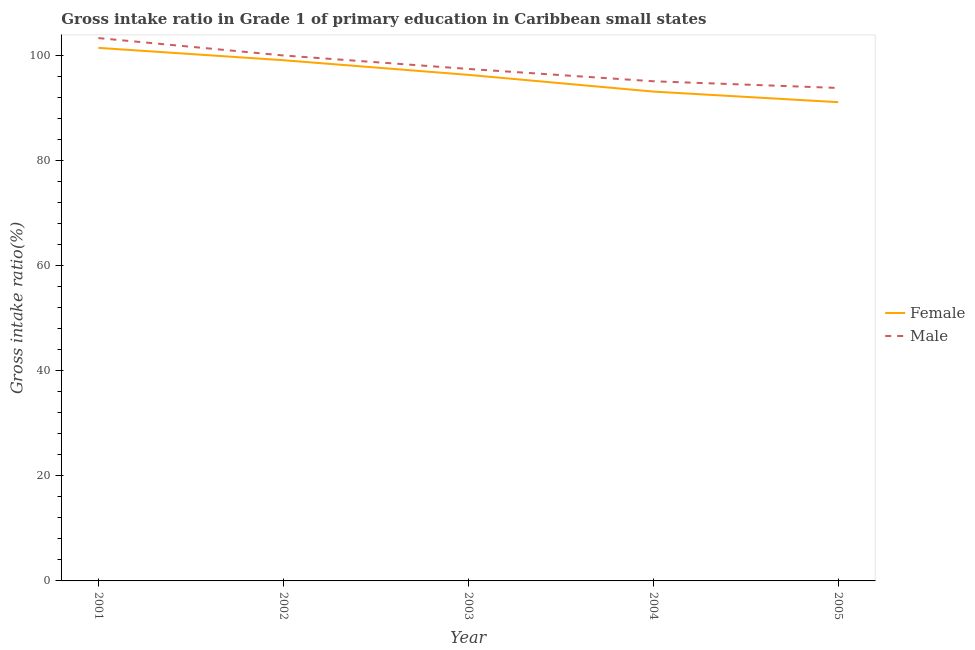How many different coloured lines are there?
Provide a short and direct response. 2. What is the gross intake ratio(male) in 2004?
Offer a very short reply. 95.14. Across all years, what is the maximum gross intake ratio(male)?
Offer a very short reply. 103.36. Across all years, what is the minimum gross intake ratio(female)?
Offer a terse response. 91.16. What is the total gross intake ratio(female) in the graph?
Offer a terse response. 481.33. What is the difference between the gross intake ratio(female) in 2004 and that in 2005?
Your response must be concise. 2.02. What is the difference between the gross intake ratio(female) in 2005 and the gross intake ratio(male) in 2001?
Your response must be concise. -12.2. What is the average gross intake ratio(male) per year?
Your response must be concise. 97.98. In the year 2005, what is the difference between the gross intake ratio(female) and gross intake ratio(male)?
Your answer should be very brief. -2.71. What is the ratio of the gross intake ratio(male) in 2004 to that in 2005?
Make the answer very short. 1.01. What is the difference between the highest and the second highest gross intake ratio(female)?
Offer a very short reply. 2.35. What is the difference between the highest and the lowest gross intake ratio(female)?
Your response must be concise. 10.34. In how many years, is the gross intake ratio(male) greater than the average gross intake ratio(male) taken over all years?
Ensure brevity in your answer.  2. Does the gross intake ratio(female) monotonically increase over the years?
Your response must be concise. No. Is the gross intake ratio(male) strictly greater than the gross intake ratio(female) over the years?
Your response must be concise. Yes. How many years are there in the graph?
Offer a very short reply. 5. What is the difference between two consecutive major ticks on the Y-axis?
Offer a very short reply. 20. Are the values on the major ticks of Y-axis written in scientific E-notation?
Your response must be concise. No. Does the graph contain grids?
Provide a short and direct response. No. How many legend labels are there?
Give a very brief answer. 2. How are the legend labels stacked?
Provide a succinct answer. Vertical. What is the title of the graph?
Your answer should be very brief. Gross intake ratio in Grade 1 of primary education in Caribbean small states. Does "GDP per capita" appear as one of the legend labels in the graph?
Your response must be concise. No. What is the label or title of the Y-axis?
Offer a terse response. Gross intake ratio(%). What is the Gross intake ratio(%) in Female in 2001?
Ensure brevity in your answer.  101.5. What is the Gross intake ratio(%) in Male in 2001?
Offer a very short reply. 103.36. What is the Gross intake ratio(%) of Female in 2002?
Give a very brief answer. 99.15. What is the Gross intake ratio(%) in Male in 2002?
Your answer should be very brief. 100.05. What is the Gross intake ratio(%) in Female in 2003?
Your answer should be very brief. 96.36. What is the Gross intake ratio(%) in Male in 2003?
Make the answer very short. 97.49. What is the Gross intake ratio(%) of Female in 2004?
Give a very brief answer. 93.17. What is the Gross intake ratio(%) in Male in 2004?
Provide a short and direct response. 95.14. What is the Gross intake ratio(%) in Female in 2005?
Your response must be concise. 91.16. What is the Gross intake ratio(%) in Male in 2005?
Provide a succinct answer. 93.86. Across all years, what is the maximum Gross intake ratio(%) of Female?
Give a very brief answer. 101.5. Across all years, what is the maximum Gross intake ratio(%) of Male?
Provide a succinct answer. 103.36. Across all years, what is the minimum Gross intake ratio(%) in Female?
Offer a terse response. 91.16. Across all years, what is the minimum Gross intake ratio(%) of Male?
Provide a succinct answer. 93.86. What is the total Gross intake ratio(%) of Female in the graph?
Your answer should be compact. 481.33. What is the total Gross intake ratio(%) in Male in the graph?
Your response must be concise. 489.9. What is the difference between the Gross intake ratio(%) of Female in 2001 and that in 2002?
Offer a terse response. 2.35. What is the difference between the Gross intake ratio(%) in Male in 2001 and that in 2002?
Make the answer very short. 3.31. What is the difference between the Gross intake ratio(%) in Female in 2001 and that in 2003?
Provide a succinct answer. 5.14. What is the difference between the Gross intake ratio(%) of Male in 2001 and that in 2003?
Provide a succinct answer. 5.87. What is the difference between the Gross intake ratio(%) in Female in 2001 and that in 2004?
Your answer should be compact. 8.32. What is the difference between the Gross intake ratio(%) of Male in 2001 and that in 2004?
Make the answer very short. 8.22. What is the difference between the Gross intake ratio(%) of Female in 2001 and that in 2005?
Provide a succinct answer. 10.34. What is the difference between the Gross intake ratio(%) in Male in 2001 and that in 2005?
Give a very brief answer. 9.5. What is the difference between the Gross intake ratio(%) of Female in 2002 and that in 2003?
Your answer should be compact. 2.79. What is the difference between the Gross intake ratio(%) of Male in 2002 and that in 2003?
Your answer should be compact. 2.56. What is the difference between the Gross intake ratio(%) in Female in 2002 and that in 2004?
Your response must be concise. 5.97. What is the difference between the Gross intake ratio(%) of Male in 2002 and that in 2004?
Provide a short and direct response. 4.91. What is the difference between the Gross intake ratio(%) of Female in 2002 and that in 2005?
Offer a terse response. 7.99. What is the difference between the Gross intake ratio(%) of Male in 2002 and that in 2005?
Offer a very short reply. 6.19. What is the difference between the Gross intake ratio(%) of Female in 2003 and that in 2004?
Ensure brevity in your answer.  3.18. What is the difference between the Gross intake ratio(%) of Male in 2003 and that in 2004?
Give a very brief answer. 2.35. What is the difference between the Gross intake ratio(%) of Female in 2003 and that in 2005?
Ensure brevity in your answer.  5.2. What is the difference between the Gross intake ratio(%) in Male in 2003 and that in 2005?
Your answer should be very brief. 3.62. What is the difference between the Gross intake ratio(%) of Female in 2004 and that in 2005?
Your answer should be compact. 2.02. What is the difference between the Gross intake ratio(%) of Male in 2004 and that in 2005?
Keep it short and to the point. 1.27. What is the difference between the Gross intake ratio(%) in Female in 2001 and the Gross intake ratio(%) in Male in 2002?
Offer a terse response. 1.45. What is the difference between the Gross intake ratio(%) in Female in 2001 and the Gross intake ratio(%) in Male in 2003?
Provide a short and direct response. 4.01. What is the difference between the Gross intake ratio(%) in Female in 2001 and the Gross intake ratio(%) in Male in 2004?
Your response must be concise. 6.36. What is the difference between the Gross intake ratio(%) of Female in 2001 and the Gross intake ratio(%) of Male in 2005?
Your answer should be compact. 7.63. What is the difference between the Gross intake ratio(%) of Female in 2002 and the Gross intake ratio(%) of Male in 2003?
Ensure brevity in your answer.  1.66. What is the difference between the Gross intake ratio(%) in Female in 2002 and the Gross intake ratio(%) in Male in 2004?
Make the answer very short. 4.01. What is the difference between the Gross intake ratio(%) of Female in 2002 and the Gross intake ratio(%) of Male in 2005?
Your answer should be compact. 5.28. What is the difference between the Gross intake ratio(%) of Female in 2003 and the Gross intake ratio(%) of Male in 2004?
Provide a short and direct response. 1.22. What is the difference between the Gross intake ratio(%) of Female in 2003 and the Gross intake ratio(%) of Male in 2005?
Your response must be concise. 2.5. What is the difference between the Gross intake ratio(%) of Female in 2004 and the Gross intake ratio(%) of Male in 2005?
Make the answer very short. -0.69. What is the average Gross intake ratio(%) of Female per year?
Ensure brevity in your answer.  96.27. What is the average Gross intake ratio(%) in Male per year?
Provide a short and direct response. 97.98. In the year 2001, what is the difference between the Gross intake ratio(%) of Female and Gross intake ratio(%) of Male?
Ensure brevity in your answer.  -1.86. In the year 2002, what is the difference between the Gross intake ratio(%) in Female and Gross intake ratio(%) in Male?
Provide a short and direct response. -0.9. In the year 2003, what is the difference between the Gross intake ratio(%) in Female and Gross intake ratio(%) in Male?
Keep it short and to the point. -1.13. In the year 2004, what is the difference between the Gross intake ratio(%) in Female and Gross intake ratio(%) in Male?
Offer a very short reply. -1.96. In the year 2005, what is the difference between the Gross intake ratio(%) in Female and Gross intake ratio(%) in Male?
Offer a very short reply. -2.71. What is the ratio of the Gross intake ratio(%) in Female in 2001 to that in 2002?
Provide a succinct answer. 1.02. What is the ratio of the Gross intake ratio(%) of Male in 2001 to that in 2002?
Give a very brief answer. 1.03. What is the ratio of the Gross intake ratio(%) of Female in 2001 to that in 2003?
Make the answer very short. 1.05. What is the ratio of the Gross intake ratio(%) in Male in 2001 to that in 2003?
Keep it short and to the point. 1.06. What is the ratio of the Gross intake ratio(%) of Female in 2001 to that in 2004?
Provide a succinct answer. 1.09. What is the ratio of the Gross intake ratio(%) in Male in 2001 to that in 2004?
Provide a succinct answer. 1.09. What is the ratio of the Gross intake ratio(%) of Female in 2001 to that in 2005?
Your response must be concise. 1.11. What is the ratio of the Gross intake ratio(%) in Male in 2001 to that in 2005?
Your answer should be very brief. 1.1. What is the ratio of the Gross intake ratio(%) in Female in 2002 to that in 2003?
Provide a short and direct response. 1.03. What is the ratio of the Gross intake ratio(%) of Male in 2002 to that in 2003?
Your response must be concise. 1.03. What is the ratio of the Gross intake ratio(%) of Female in 2002 to that in 2004?
Provide a succinct answer. 1.06. What is the ratio of the Gross intake ratio(%) of Male in 2002 to that in 2004?
Provide a succinct answer. 1.05. What is the ratio of the Gross intake ratio(%) of Female in 2002 to that in 2005?
Offer a very short reply. 1.09. What is the ratio of the Gross intake ratio(%) of Male in 2002 to that in 2005?
Offer a terse response. 1.07. What is the ratio of the Gross intake ratio(%) of Female in 2003 to that in 2004?
Give a very brief answer. 1.03. What is the ratio of the Gross intake ratio(%) in Male in 2003 to that in 2004?
Offer a terse response. 1.02. What is the ratio of the Gross intake ratio(%) in Female in 2003 to that in 2005?
Your answer should be compact. 1.06. What is the ratio of the Gross intake ratio(%) in Male in 2003 to that in 2005?
Make the answer very short. 1.04. What is the ratio of the Gross intake ratio(%) of Female in 2004 to that in 2005?
Provide a short and direct response. 1.02. What is the ratio of the Gross intake ratio(%) in Male in 2004 to that in 2005?
Offer a very short reply. 1.01. What is the difference between the highest and the second highest Gross intake ratio(%) of Female?
Your response must be concise. 2.35. What is the difference between the highest and the second highest Gross intake ratio(%) of Male?
Offer a terse response. 3.31. What is the difference between the highest and the lowest Gross intake ratio(%) of Female?
Ensure brevity in your answer.  10.34. What is the difference between the highest and the lowest Gross intake ratio(%) in Male?
Your response must be concise. 9.5. 